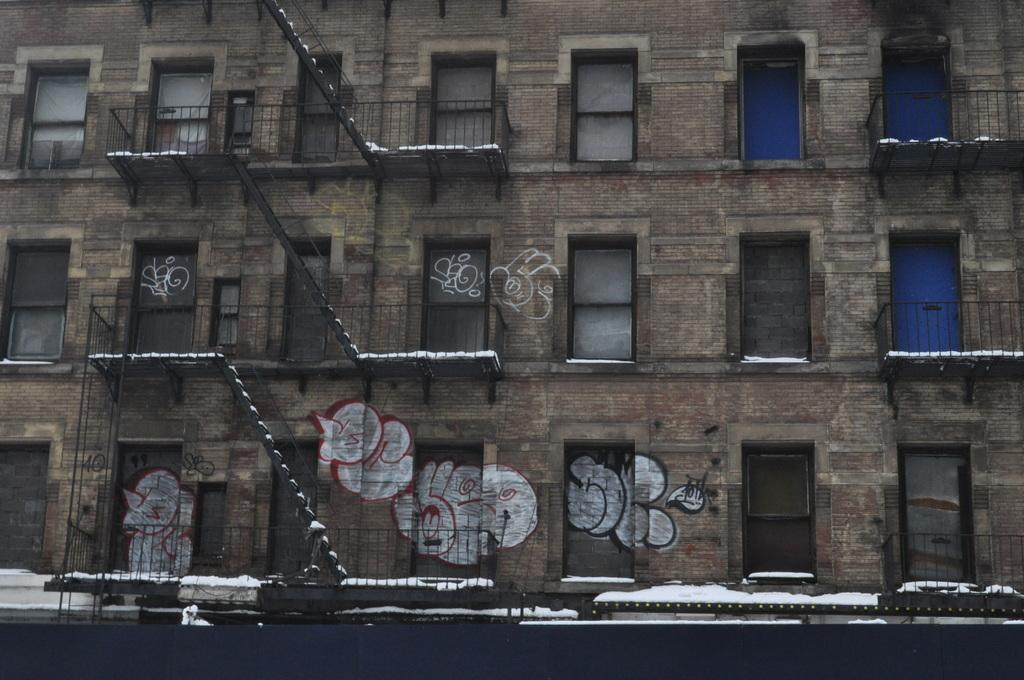What type of structure is visible in the image? There is a building in the image. What feature of the building is mentioned in the facts? The building has stairs and windows. What is the weather condition in the image? There is snow on the building, indicating a cold or wintry condition. Is there any artwork on the building? Yes, there is a painting on the building. How many letters are visible on the painting on the building? There is no information about letters on the painting in the provided facts, so we cannot determine the number of letters. Additionally, the question is irrelevant to the image as it focuses on a detail that is not mentioned in the facts. 